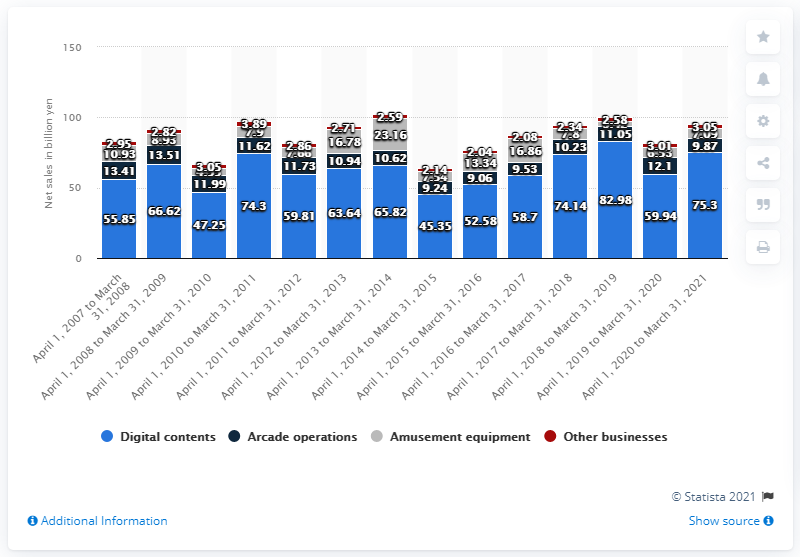Specify some key components in this picture. Capcom generated approximately 75.3 billion yen in revenue in 2021. 